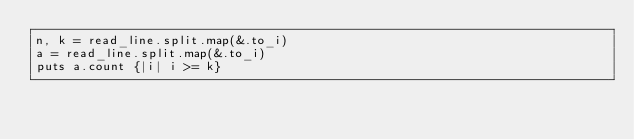<code> <loc_0><loc_0><loc_500><loc_500><_Crystal_>n, k = read_line.split.map(&.to_i)
a = read_line.split.map(&.to_i)
puts a.count {|i| i >= k}</code> 